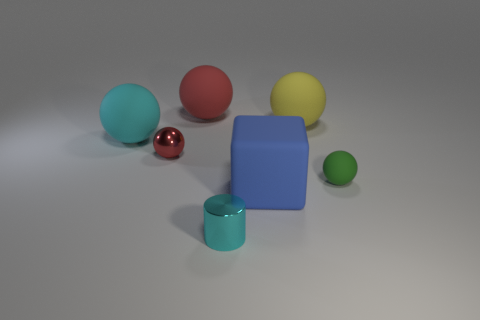Is the number of green objects greater than the number of matte objects? No, the number of green objects is not greater. There are two green objects, and there are at least three objects that appear to have a matte finish. 